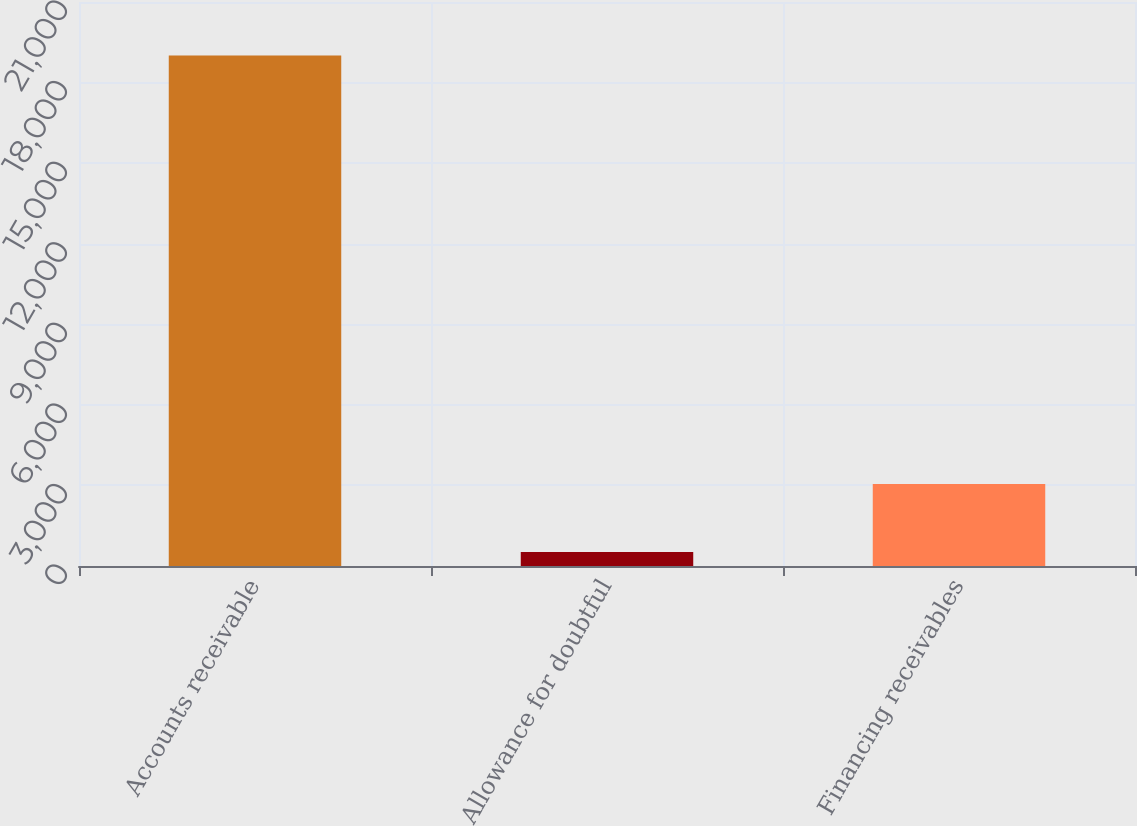Convert chart. <chart><loc_0><loc_0><loc_500><loc_500><bar_chart><fcel>Accounts receivable<fcel>Allowance for doubtful<fcel>Financing receivables<nl><fcel>19006<fcel>525<fcel>3050<nl></chart> 